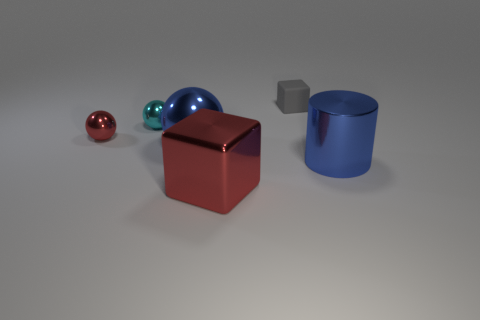Subtract all small balls. How many balls are left? 1 Subtract all gray blocks. How many blocks are left? 1 Subtract 1 cylinders. How many cylinders are left? 0 Add 1 small gray matte things. How many objects exist? 7 Subtract all cylinders. How many objects are left? 5 Subtract all blue cubes. How many red cylinders are left? 0 Subtract all large blue metallic things. Subtract all blue metal cylinders. How many objects are left? 3 Add 4 gray matte objects. How many gray matte objects are left? 5 Add 3 cyan metallic spheres. How many cyan metallic spheres exist? 4 Subtract 0 cyan cylinders. How many objects are left? 6 